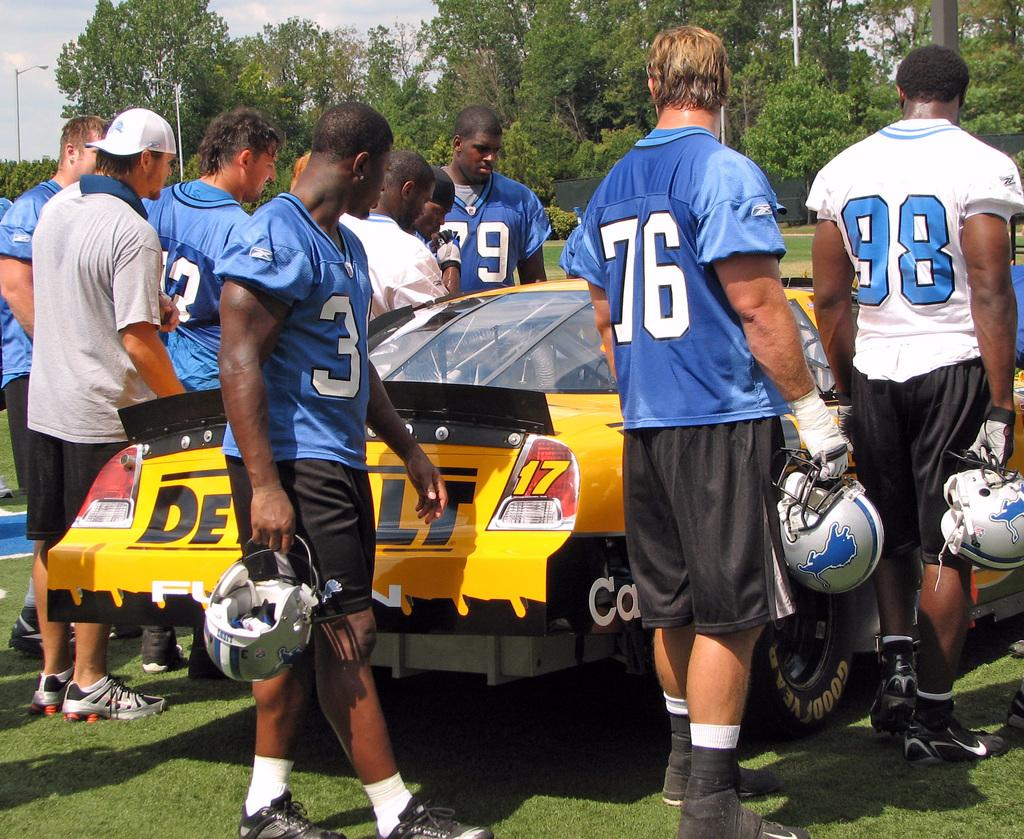What can be seen in the foreground of the picture? There are people and a car in the foreground of the picture. What type of vegetation is present in the foreground of the picture? There is grass in the foreground of the picture. What can be seen in the background of the picture? There are trees, plants, a black curtain, and street lights in the background of the picture. What is visible at the top of the image? The sky is visible at the top of the image. Where is the shelf located in the image? There is no shelf present in the image. Are there any giants visible in the image? There are no giants present in the image. What type of hat is the person in the image wearing? There is no person wearing a hat in the image. 